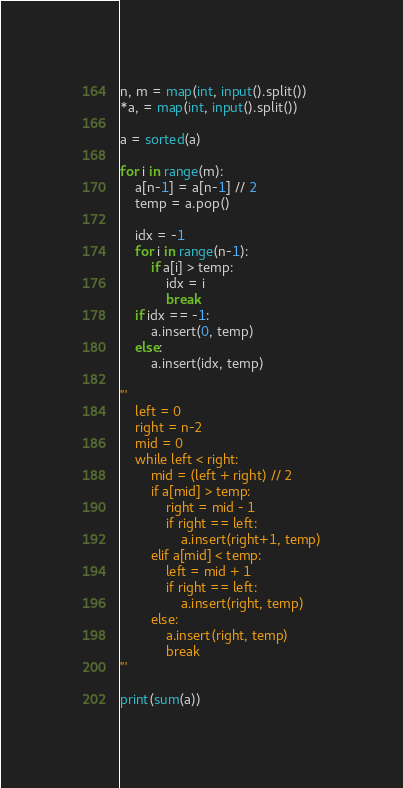Convert code to text. <code><loc_0><loc_0><loc_500><loc_500><_Python_>n, m = map(int, input().split())
*a, = map(int, input().split())

a = sorted(a)

for i in range(m):
    a[n-1] = a[n-1] // 2
    temp = a.pop()

    idx = -1
    for i in range(n-1):
        if a[i] > temp:
            idx = i
            break
    if idx == -1:
        a.insert(0, temp)
    else:
        a.insert(idx, temp)

'''
    left = 0
    right = n-2
    mid = 0
    while left < right:
        mid = (left + right) // 2
        if a[mid] > temp:
            right = mid - 1
            if right == left:
                a.insert(right+1, temp)
        elif a[mid] < temp:
            left = mid + 1
            if right == left:
                a.insert(right, temp)
        else:
            a.insert(right, temp)
            break
'''
    
print(sum(a))</code> 